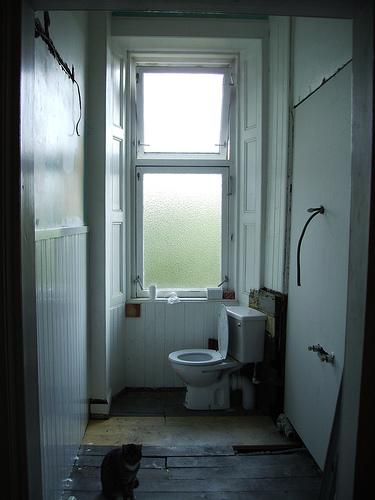Is a window near a toilet a good idea?
Be succinct. Yes. Are all the windows open?
Answer briefly. No. Does this bathroom offer privacy and seclusion?
Write a very short answer. No. Why is there frosted glass on the window?
Concise answer only. Privacy. Is this bathroom salvageable?
Write a very short answer. Yes. Does the window let in light?
Keep it brief. Yes. Is the toilet behind a glass wall?
Answer briefly. No. Is the bathroom functional?
Answer briefly. Yes. What is the name of the sink fixture that the water comes out of?
Concise answer only. Faucet. Is this bathroom clean?
Keep it brief. Yes. 